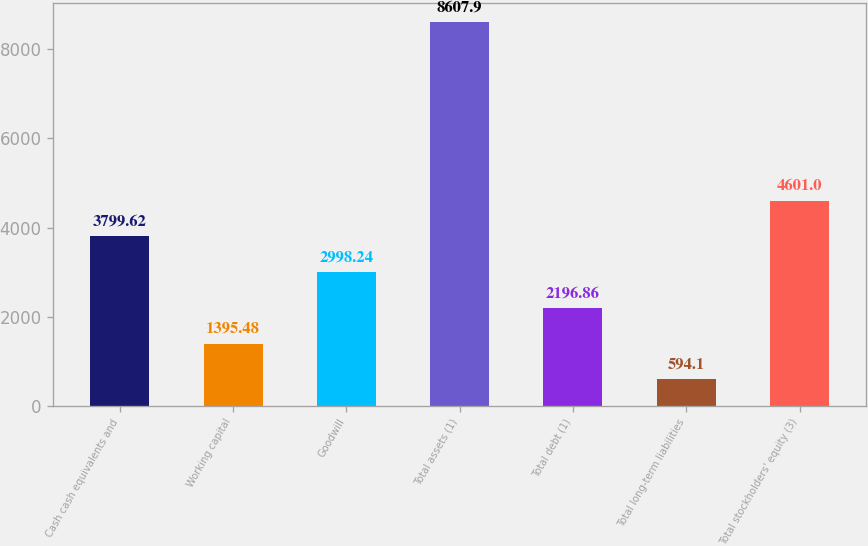Convert chart to OTSL. <chart><loc_0><loc_0><loc_500><loc_500><bar_chart><fcel>Cash cash equivalents and<fcel>Working capital<fcel>Goodwill<fcel>Total assets (1)<fcel>Total debt (1)<fcel>Total long-term liabilities<fcel>Total stockholders' equity (3)<nl><fcel>3799.62<fcel>1395.48<fcel>2998.24<fcel>8607.9<fcel>2196.86<fcel>594.1<fcel>4601<nl></chart> 